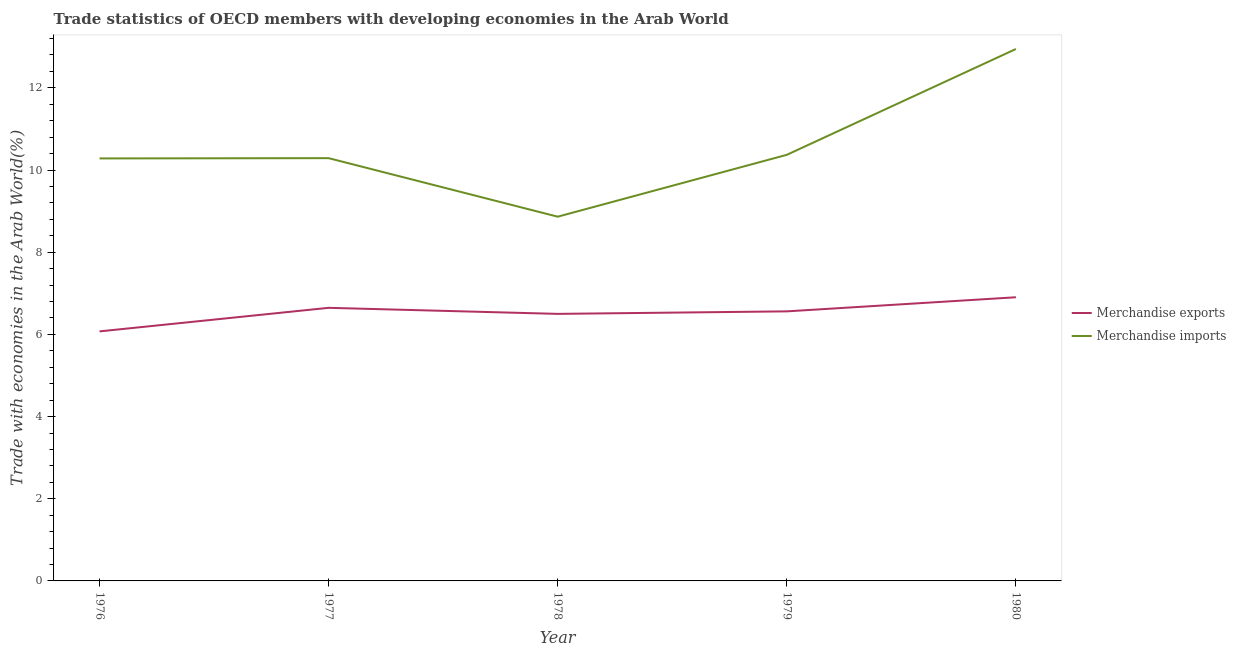How many different coloured lines are there?
Make the answer very short. 2. Is the number of lines equal to the number of legend labels?
Provide a succinct answer. Yes. What is the merchandise imports in 1977?
Your answer should be compact. 10.29. Across all years, what is the maximum merchandise exports?
Offer a very short reply. 6.9. Across all years, what is the minimum merchandise exports?
Provide a succinct answer. 6.07. In which year was the merchandise imports minimum?
Offer a very short reply. 1978. What is the total merchandise imports in the graph?
Your answer should be very brief. 52.75. What is the difference between the merchandise imports in 1977 and that in 1979?
Your answer should be very brief. -0.08. What is the difference between the merchandise imports in 1976 and the merchandise exports in 1977?
Make the answer very short. 3.64. What is the average merchandise exports per year?
Give a very brief answer. 6.54. In the year 1977, what is the difference between the merchandise exports and merchandise imports?
Your answer should be compact. -3.64. In how many years, is the merchandise exports greater than 6.8 %?
Provide a succinct answer. 1. What is the ratio of the merchandise imports in 1976 to that in 1979?
Ensure brevity in your answer.  0.99. What is the difference between the highest and the second highest merchandise imports?
Offer a terse response. 2.58. What is the difference between the highest and the lowest merchandise imports?
Provide a short and direct response. 4.08. In how many years, is the merchandise imports greater than the average merchandise imports taken over all years?
Your response must be concise. 1. Does the merchandise imports monotonically increase over the years?
Make the answer very short. No. How many years are there in the graph?
Keep it short and to the point. 5. Are the values on the major ticks of Y-axis written in scientific E-notation?
Ensure brevity in your answer.  No. Does the graph contain any zero values?
Ensure brevity in your answer.  No. What is the title of the graph?
Offer a terse response. Trade statistics of OECD members with developing economies in the Arab World. Does "Arms imports" appear as one of the legend labels in the graph?
Provide a short and direct response. No. What is the label or title of the X-axis?
Your answer should be compact. Year. What is the label or title of the Y-axis?
Your answer should be very brief. Trade with economies in the Arab World(%). What is the Trade with economies in the Arab World(%) of Merchandise exports in 1976?
Your response must be concise. 6.07. What is the Trade with economies in the Arab World(%) in Merchandise imports in 1976?
Your answer should be very brief. 10.28. What is the Trade with economies in the Arab World(%) in Merchandise exports in 1977?
Your answer should be compact. 6.65. What is the Trade with economies in the Arab World(%) of Merchandise imports in 1977?
Offer a terse response. 10.29. What is the Trade with economies in the Arab World(%) in Merchandise exports in 1978?
Provide a succinct answer. 6.5. What is the Trade with economies in the Arab World(%) in Merchandise imports in 1978?
Offer a very short reply. 8.86. What is the Trade with economies in the Arab World(%) of Merchandise exports in 1979?
Make the answer very short. 6.56. What is the Trade with economies in the Arab World(%) of Merchandise imports in 1979?
Your response must be concise. 10.37. What is the Trade with economies in the Arab World(%) in Merchandise exports in 1980?
Ensure brevity in your answer.  6.9. What is the Trade with economies in the Arab World(%) in Merchandise imports in 1980?
Ensure brevity in your answer.  12.95. Across all years, what is the maximum Trade with economies in the Arab World(%) of Merchandise exports?
Your answer should be very brief. 6.9. Across all years, what is the maximum Trade with economies in the Arab World(%) of Merchandise imports?
Provide a succinct answer. 12.95. Across all years, what is the minimum Trade with economies in the Arab World(%) in Merchandise exports?
Give a very brief answer. 6.07. Across all years, what is the minimum Trade with economies in the Arab World(%) of Merchandise imports?
Keep it short and to the point. 8.86. What is the total Trade with economies in the Arab World(%) of Merchandise exports in the graph?
Your response must be concise. 32.68. What is the total Trade with economies in the Arab World(%) in Merchandise imports in the graph?
Your response must be concise. 52.75. What is the difference between the Trade with economies in the Arab World(%) of Merchandise exports in 1976 and that in 1977?
Keep it short and to the point. -0.57. What is the difference between the Trade with economies in the Arab World(%) of Merchandise imports in 1976 and that in 1977?
Your answer should be compact. -0.01. What is the difference between the Trade with economies in the Arab World(%) of Merchandise exports in 1976 and that in 1978?
Provide a succinct answer. -0.43. What is the difference between the Trade with economies in the Arab World(%) in Merchandise imports in 1976 and that in 1978?
Your response must be concise. 1.42. What is the difference between the Trade with economies in the Arab World(%) in Merchandise exports in 1976 and that in 1979?
Your response must be concise. -0.49. What is the difference between the Trade with economies in the Arab World(%) in Merchandise imports in 1976 and that in 1979?
Offer a very short reply. -0.09. What is the difference between the Trade with economies in the Arab World(%) of Merchandise exports in 1976 and that in 1980?
Your answer should be very brief. -0.83. What is the difference between the Trade with economies in the Arab World(%) of Merchandise imports in 1976 and that in 1980?
Provide a succinct answer. -2.66. What is the difference between the Trade with economies in the Arab World(%) of Merchandise exports in 1977 and that in 1978?
Ensure brevity in your answer.  0.15. What is the difference between the Trade with economies in the Arab World(%) in Merchandise imports in 1977 and that in 1978?
Provide a short and direct response. 1.42. What is the difference between the Trade with economies in the Arab World(%) of Merchandise exports in 1977 and that in 1979?
Your answer should be very brief. 0.09. What is the difference between the Trade with economies in the Arab World(%) in Merchandise imports in 1977 and that in 1979?
Offer a very short reply. -0.08. What is the difference between the Trade with economies in the Arab World(%) of Merchandise exports in 1977 and that in 1980?
Keep it short and to the point. -0.26. What is the difference between the Trade with economies in the Arab World(%) of Merchandise imports in 1977 and that in 1980?
Your answer should be very brief. -2.66. What is the difference between the Trade with economies in the Arab World(%) in Merchandise exports in 1978 and that in 1979?
Your response must be concise. -0.06. What is the difference between the Trade with economies in the Arab World(%) in Merchandise imports in 1978 and that in 1979?
Provide a short and direct response. -1.51. What is the difference between the Trade with economies in the Arab World(%) in Merchandise exports in 1978 and that in 1980?
Provide a succinct answer. -0.4. What is the difference between the Trade with economies in the Arab World(%) in Merchandise imports in 1978 and that in 1980?
Your answer should be compact. -4.08. What is the difference between the Trade with economies in the Arab World(%) of Merchandise exports in 1979 and that in 1980?
Give a very brief answer. -0.34. What is the difference between the Trade with economies in the Arab World(%) of Merchandise imports in 1979 and that in 1980?
Keep it short and to the point. -2.58. What is the difference between the Trade with economies in the Arab World(%) of Merchandise exports in 1976 and the Trade with economies in the Arab World(%) of Merchandise imports in 1977?
Ensure brevity in your answer.  -4.22. What is the difference between the Trade with economies in the Arab World(%) of Merchandise exports in 1976 and the Trade with economies in the Arab World(%) of Merchandise imports in 1978?
Give a very brief answer. -2.79. What is the difference between the Trade with economies in the Arab World(%) of Merchandise exports in 1976 and the Trade with economies in the Arab World(%) of Merchandise imports in 1979?
Your answer should be very brief. -4.3. What is the difference between the Trade with economies in the Arab World(%) in Merchandise exports in 1976 and the Trade with economies in the Arab World(%) in Merchandise imports in 1980?
Your answer should be compact. -6.87. What is the difference between the Trade with economies in the Arab World(%) in Merchandise exports in 1977 and the Trade with economies in the Arab World(%) in Merchandise imports in 1978?
Your answer should be very brief. -2.22. What is the difference between the Trade with economies in the Arab World(%) in Merchandise exports in 1977 and the Trade with economies in the Arab World(%) in Merchandise imports in 1979?
Ensure brevity in your answer.  -3.72. What is the difference between the Trade with economies in the Arab World(%) of Merchandise exports in 1977 and the Trade with economies in the Arab World(%) of Merchandise imports in 1980?
Offer a terse response. -6.3. What is the difference between the Trade with economies in the Arab World(%) of Merchandise exports in 1978 and the Trade with economies in the Arab World(%) of Merchandise imports in 1979?
Give a very brief answer. -3.87. What is the difference between the Trade with economies in the Arab World(%) of Merchandise exports in 1978 and the Trade with economies in the Arab World(%) of Merchandise imports in 1980?
Make the answer very short. -6.45. What is the difference between the Trade with economies in the Arab World(%) of Merchandise exports in 1979 and the Trade with economies in the Arab World(%) of Merchandise imports in 1980?
Your answer should be very brief. -6.39. What is the average Trade with economies in the Arab World(%) of Merchandise exports per year?
Your response must be concise. 6.54. What is the average Trade with economies in the Arab World(%) of Merchandise imports per year?
Make the answer very short. 10.55. In the year 1976, what is the difference between the Trade with economies in the Arab World(%) of Merchandise exports and Trade with economies in the Arab World(%) of Merchandise imports?
Make the answer very short. -4.21. In the year 1977, what is the difference between the Trade with economies in the Arab World(%) of Merchandise exports and Trade with economies in the Arab World(%) of Merchandise imports?
Your answer should be very brief. -3.64. In the year 1978, what is the difference between the Trade with economies in the Arab World(%) of Merchandise exports and Trade with economies in the Arab World(%) of Merchandise imports?
Offer a very short reply. -2.37. In the year 1979, what is the difference between the Trade with economies in the Arab World(%) in Merchandise exports and Trade with economies in the Arab World(%) in Merchandise imports?
Your answer should be very brief. -3.81. In the year 1980, what is the difference between the Trade with economies in the Arab World(%) of Merchandise exports and Trade with economies in the Arab World(%) of Merchandise imports?
Your answer should be very brief. -6.04. What is the ratio of the Trade with economies in the Arab World(%) in Merchandise exports in 1976 to that in 1977?
Provide a short and direct response. 0.91. What is the ratio of the Trade with economies in the Arab World(%) in Merchandise exports in 1976 to that in 1978?
Your response must be concise. 0.93. What is the ratio of the Trade with economies in the Arab World(%) in Merchandise imports in 1976 to that in 1978?
Provide a short and direct response. 1.16. What is the ratio of the Trade with economies in the Arab World(%) in Merchandise exports in 1976 to that in 1979?
Your answer should be compact. 0.93. What is the ratio of the Trade with economies in the Arab World(%) of Merchandise exports in 1976 to that in 1980?
Your answer should be compact. 0.88. What is the ratio of the Trade with economies in the Arab World(%) of Merchandise imports in 1976 to that in 1980?
Your response must be concise. 0.79. What is the ratio of the Trade with economies in the Arab World(%) of Merchandise exports in 1977 to that in 1978?
Offer a very short reply. 1.02. What is the ratio of the Trade with economies in the Arab World(%) in Merchandise imports in 1977 to that in 1978?
Your answer should be very brief. 1.16. What is the ratio of the Trade with economies in the Arab World(%) of Merchandise exports in 1977 to that in 1979?
Offer a very short reply. 1.01. What is the ratio of the Trade with economies in the Arab World(%) of Merchandise exports in 1977 to that in 1980?
Offer a terse response. 0.96. What is the ratio of the Trade with economies in the Arab World(%) of Merchandise imports in 1977 to that in 1980?
Make the answer very short. 0.79. What is the ratio of the Trade with economies in the Arab World(%) in Merchandise exports in 1978 to that in 1979?
Offer a terse response. 0.99. What is the ratio of the Trade with economies in the Arab World(%) of Merchandise imports in 1978 to that in 1979?
Make the answer very short. 0.85. What is the ratio of the Trade with economies in the Arab World(%) of Merchandise exports in 1978 to that in 1980?
Provide a succinct answer. 0.94. What is the ratio of the Trade with economies in the Arab World(%) of Merchandise imports in 1978 to that in 1980?
Offer a very short reply. 0.68. What is the ratio of the Trade with economies in the Arab World(%) of Merchandise exports in 1979 to that in 1980?
Provide a short and direct response. 0.95. What is the ratio of the Trade with economies in the Arab World(%) in Merchandise imports in 1979 to that in 1980?
Offer a very short reply. 0.8. What is the difference between the highest and the second highest Trade with economies in the Arab World(%) of Merchandise exports?
Your answer should be very brief. 0.26. What is the difference between the highest and the second highest Trade with economies in the Arab World(%) of Merchandise imports?
Offer a terse response. 2.58. What is the difference between the highest and the lowest Trade with economies in the Arab World(%) in Merchandise exports?
Provide a short and direct response. 0.83. What is the difference between the highest and the lowest Trade with economies in the Arab World(%) of Merchandise imports?
Provide a succinct answer. 4.08. 